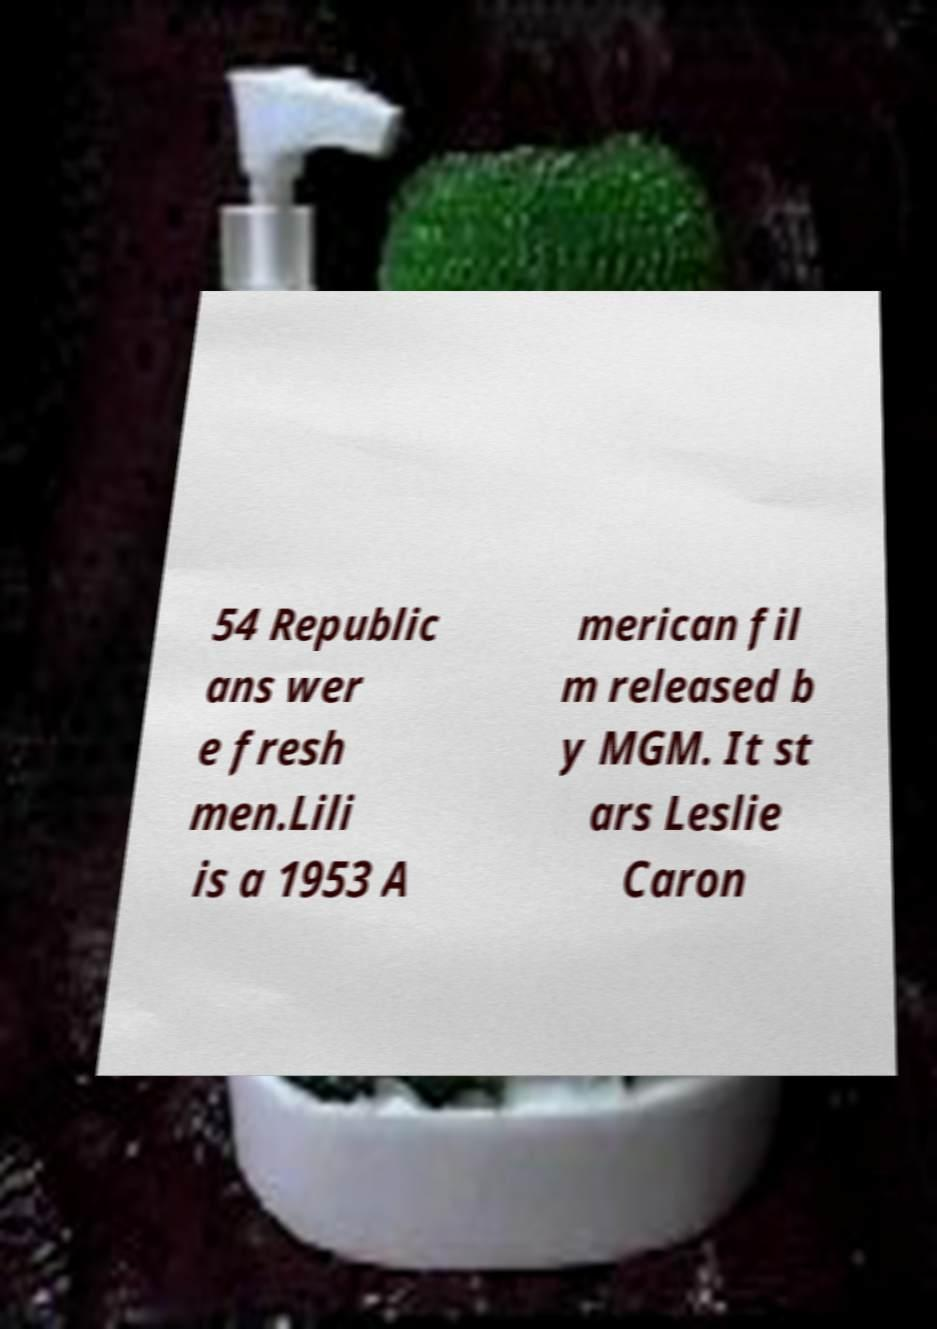Could you extract and type out the text from this image? 54 Republic ans wer e fresh men.Lili is a 1953 A merican fil m released b y MGM. It st ars Leslie Caron 